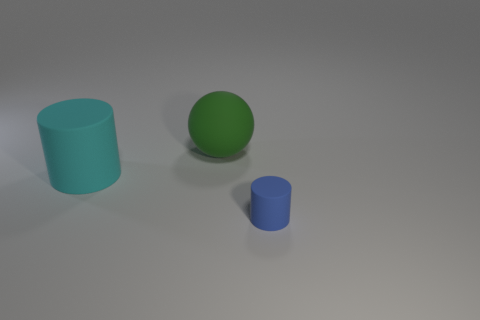What may be the purpose of these objects? These objects could serve illustrative purposes, perhaps for a study in geometry or a demonstration of 3D rendering techniques. Can these objects tell us about lighting and perspective? Indeed, the shadows and the size variation among the objects provide insights into the direction and intensity of the light source, as well as offering a sense of perspective and depth in the image. 